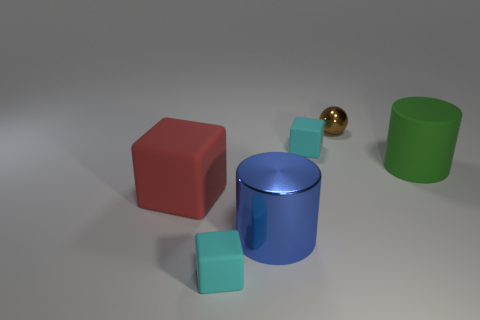Add 1 big metal things. How many objects exist? 7 Subtract all cylinders. How many objects are left? 4 Add 6 tiny rubber things. How many tiny rubber things exist? 8 Subtract 0 gray spheres. How many objects are left? 6 Subtract all big green objects. Subtract all small brown objects. How many objects are left? 4 Add 5 tiny objects. How many tiny objects are left? 8 